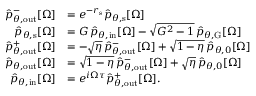<formula> <loc_0><loc_0><loc_500><loc_500>\begin{array} { r l } { \hat { p } _ { \theta , o u t } ^ { - } [ \Omega ] } & { = e ^ { - r _ { s } } \hat { p } _ { \theta , s } [ \Omega ] } \\ { \hat { p } _ { \theta , s } [ \Omega ] } & { = G \, \hat { p } _ { \theta , i n } [ \Omega ] - \sqrt { G ^ { 2 } - 1 } \, \hat { p } _ { \theta , G } [ \Omega ] } \\ { \hat { p } _ { \theta , o u t } ^ { + } [ \Omega ] } & { = - \sqrt { \eta } \, \hat { p } _ { \theta , o u t } ^ { - } [ \Omega ] + \sqrt { 1 - \eta } \, \hat { p } _ { \theta , 0 } [ \Omega ] } \\ { \hat { p } _ { \theta , o u t } [ \Omega ] } & { = \sqrt { 1 - \eta } \, \hat { p } _ { \theta , o u t } ^ { - } [ \Omega ] + \sqrt { \eta } \, \hat { p } _ { \theta , 0 } [ \Omega ] } \\ { \hat { p } _ { \theta , i n } [ \Omega ] } & { = e ^ { i \Omega \tau } \hat { p } _ { \theta , o u t } ^ { + } [ \Omega ] . } \end{array}</formula> 